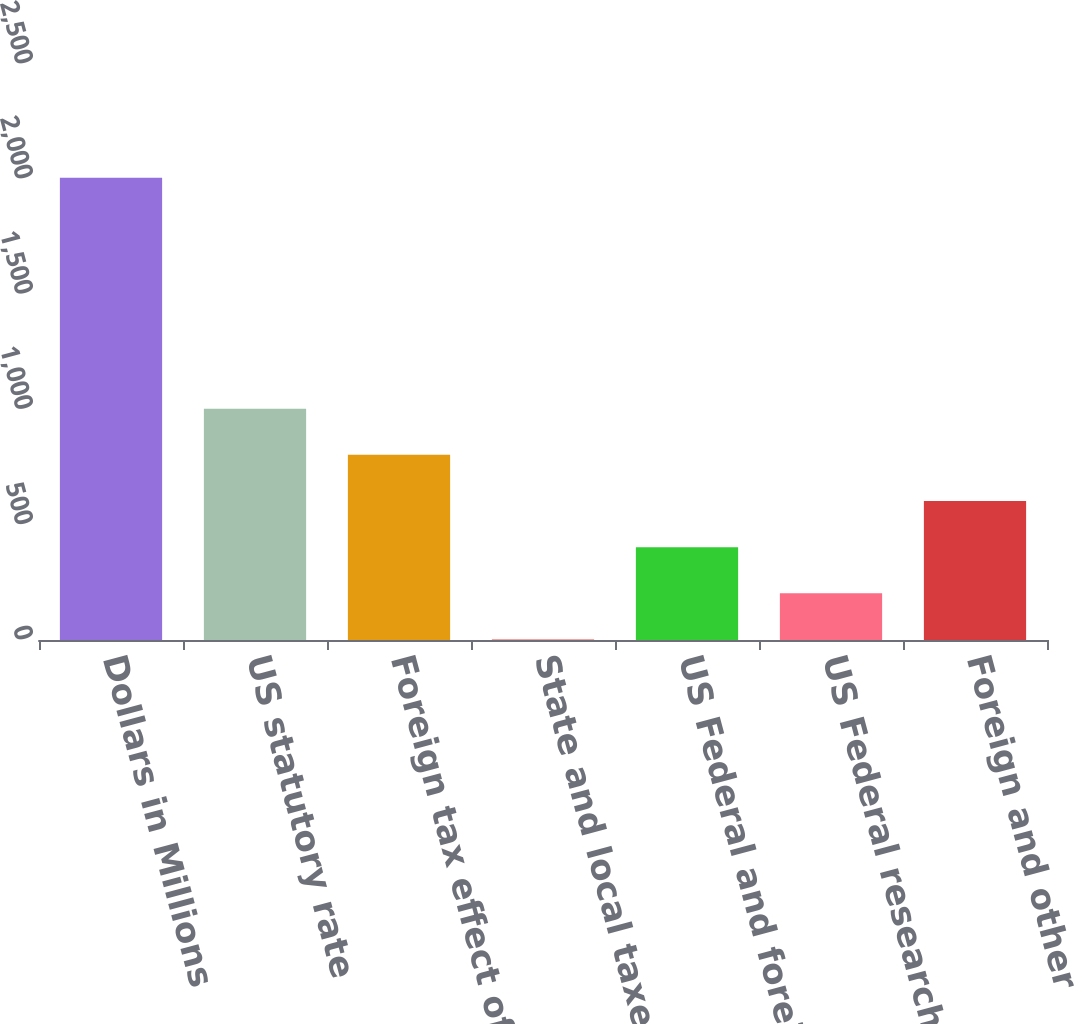Convert chart to OTSL. <chart><loc_0><loc_0><loc_500><loc_500><bar_chart><fcel>Dollars in Millions<fcel>US statutory rate<fcel>Foreign tax effect of<fcel>State and local taxes (net of<fcel>US Federal and foreign<fcel>US Federal research and<fcel>Foreign and other<nl><fcel>2006<fcel>1004<fcel>803.6<fcel>2<fcel>402.8<fcel>202.4<fcel>603.2<nl></chart> 